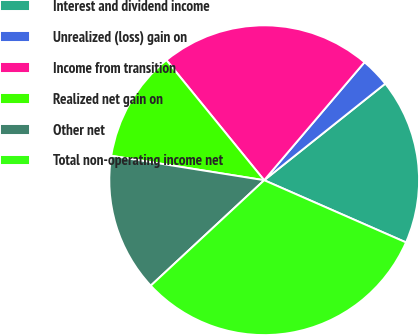<chart> <loc_0><loc_0><loc_500><loc_500><pie_chart><fcel>Interest and dividend income<fcel>Unrealized (loss) gain on<fcel>Income from transition<fcel>Realized net gain on<fcel>Other net<fcel>Total non-operating income net<nl><fcel>17.29%<fcel>3.07%<fcel>22.09%<fcel>11.6%<fcel>14.44%<fcel>31.5%<nl></chart> 